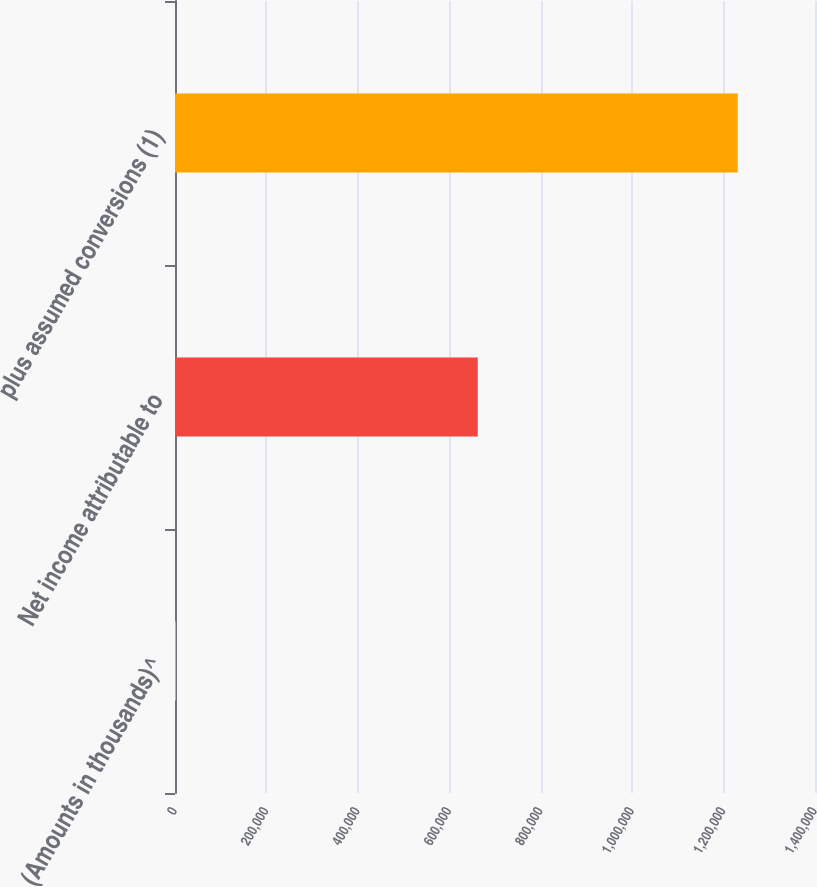Convert chart to OTSL. <chart><loc_0><loc_0><loc_500><loc_500><bar_chart><fcel>(Amounts in thousands)^<fcel>Net income attributable to<fcel>plus assumed conversions (1)<nl><fcel>2011<fcel>662302<fcel>1.23097e+06<nl></chart> 